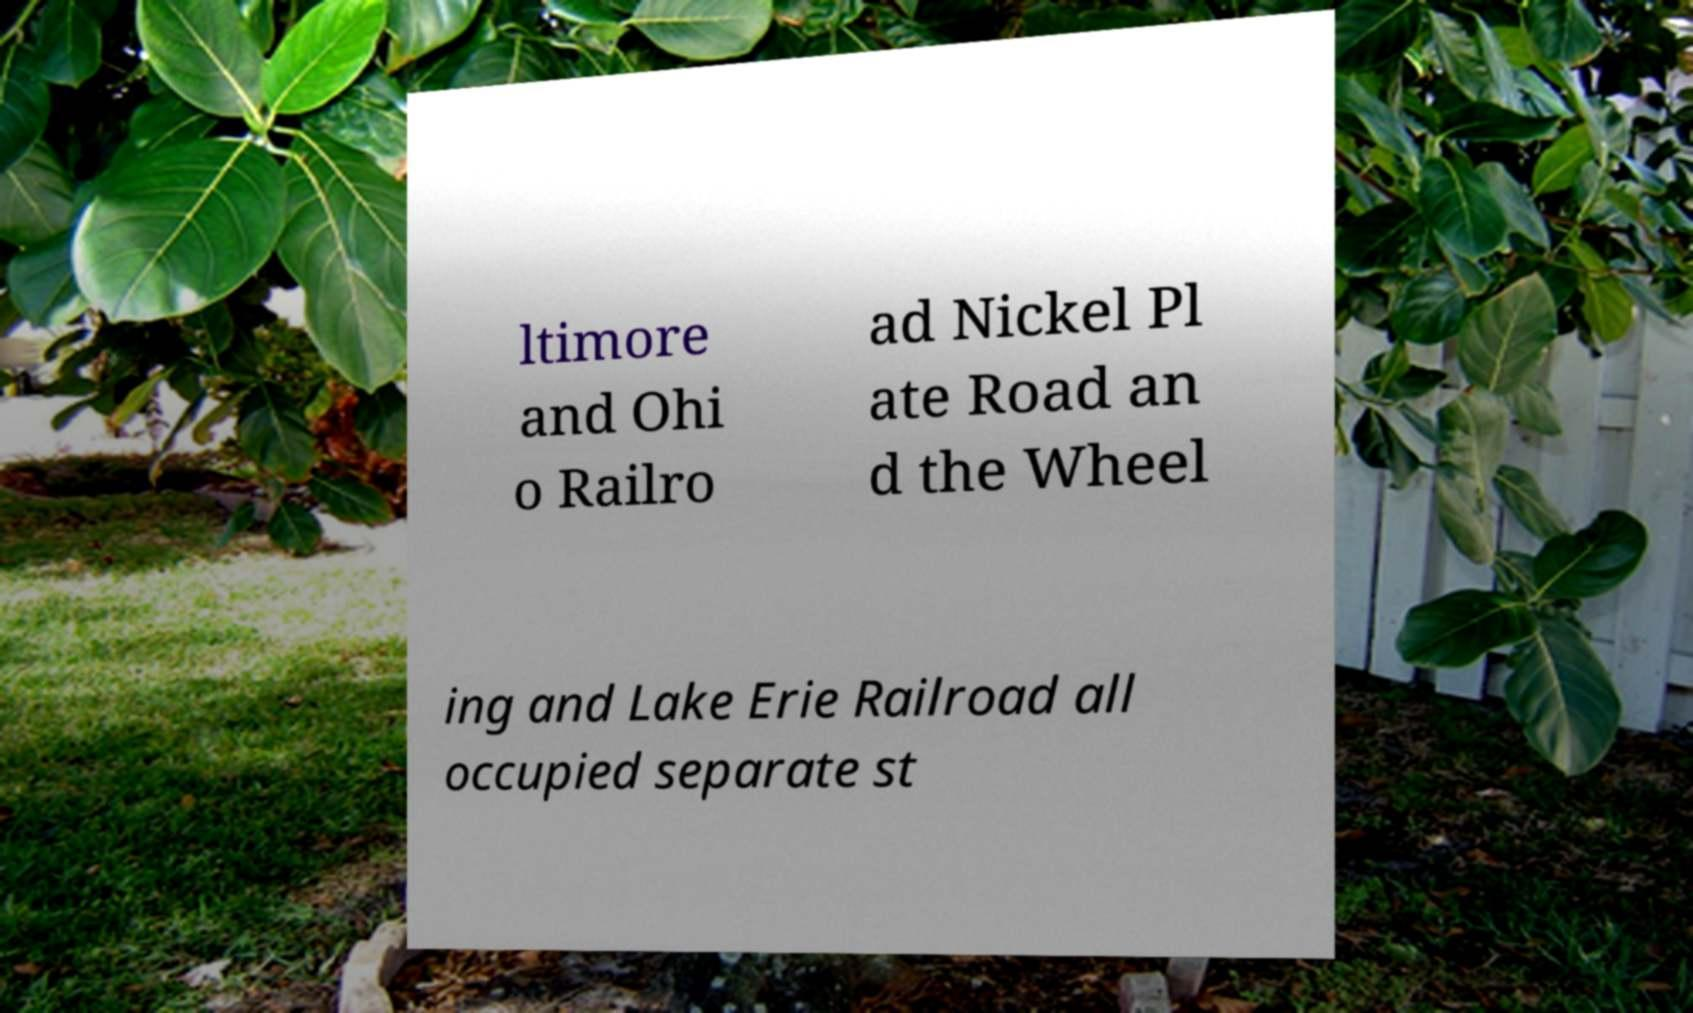For documentation purposes, I need the text within this image transcribed. Could you provide that? ltimore and Ohi o Railro ad Nickel Pl ate Road an d the Wheel ing and Lake Erie Railroad all occupied separate st 